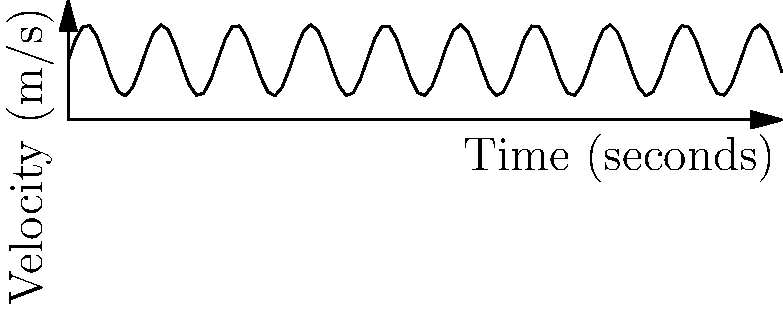During a football game, a wide receiver's velocity (in meters per second) as a function of time (in seconds) is represented by the equation $v(t) = 5 + 3\sin(t)$ for $0 \leq t \leq 60$. Using the velocity-time graph above, determine the total distance covered by the receiver during this 60-second interval. To find the total distance covered, we need to calculate the area under the velocity-time curve. This can be done using a definite integral.

Step 1: Set up the integral
The distance is given by $\int_{0}^{60} v(t) dt$

Step 2: Substitute the velocity function
$\int_{0}^{60} (5 + 3\sin(t)) dt$

Step 3: Integrate
$= [5t - 3\cos(t)]_{0}^{60}$

Step 4: Evaluate the integral
$= (5 \cdot 60 - 3\cos(60)) - (5 \cdot 0 - 3\cos(0))$
$= (300 - 3\cos(60)) - (-3)$
$= 300 - 3\cos(60) + 3$

Step 5: Simplify
$= 303 - 3\cos(60)$

The total distance covered is $303 - 3\cos(60)$ meters.
Answer: $303 - 3\cos(60)$ meters 